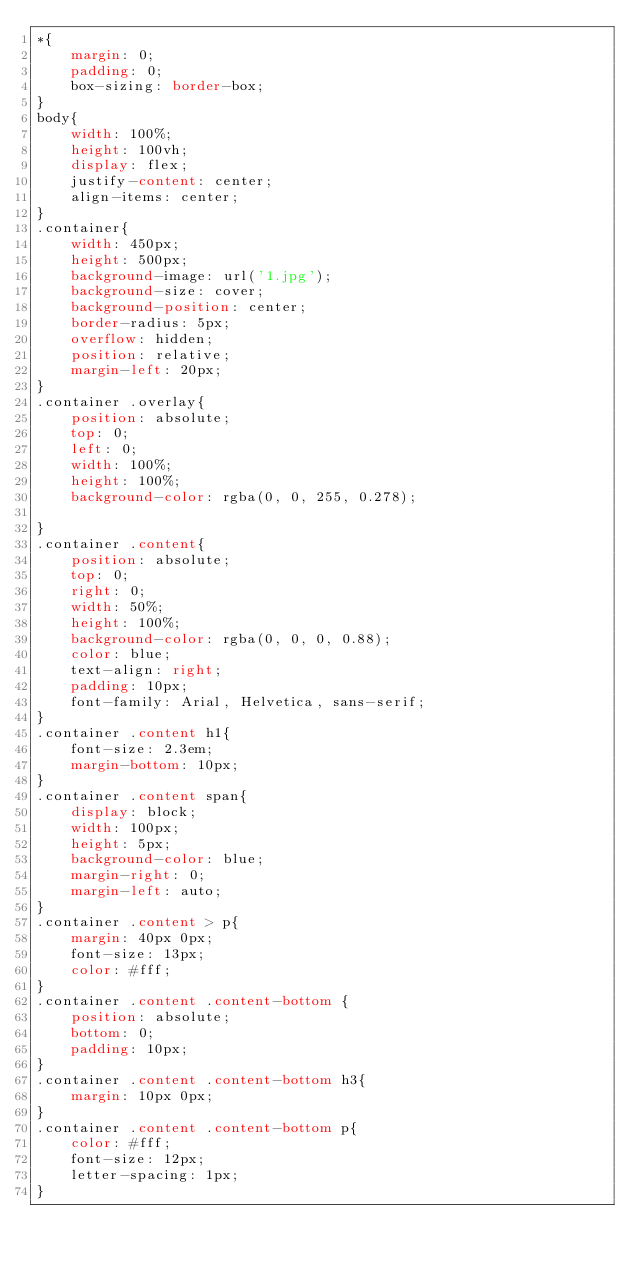Convert code to text. <code><loc_0><loc_0><loc_500><loc_500><_CSS_>*{
	margin: 0;
	padding: 0;
	box-sizing: border-box;
}
body{
	width: 100%;
	height: 100vh;
	display: flex;
	justify-content: center;
	align-items: center;
}
.container{
	width: 450px;
	height: 500px;
	background-image: url('1.jpg');
	background-size: cover;
	background-position: center;
	border-radius: 5px;
	overflow: hidden;
	position: relative;
	margin-left: 20px;
}
.container .overlay{
	position: absolute;
	top: 0;
	left: 0;
	width: 100%;
	height: 100%;
	background-color: rgba(0, 0, 255, 0.278);

}
.container .content{
	position: absolute;
	top: 0;
	right: 0;
	width: 50%;
	height: 100%;
	background-color: rgba(0, 0, 0, 0.88);
	color: blue;
	text-align: right;
	padding: 10px;
	font-family: Arial, Helvetica, sans-serif;
}
.container .content h1{
	font-size: 2.3em;
	margin-bottom: 10px;
}
.container .content span{
	display: block;
	width: 100px;
	height: 5px;
	background-color: blue;
	margin-right: 0;
	margin-left: auto;
}
.container .content > p{
	margin: 40px 0px;
	font-size: 13px;
	color: #fff;
}
.container .content .content-bottom {
	position: absolute;
	bottom: 0;
	padding: 10px;
}
.container .content .content-bottom h3{
	margin: 10px 0px;
}
.container .content .content-bottom p{
	color: #fff;
	font-size: 12px;
	letter-spacing: 1px;
}
</code> 